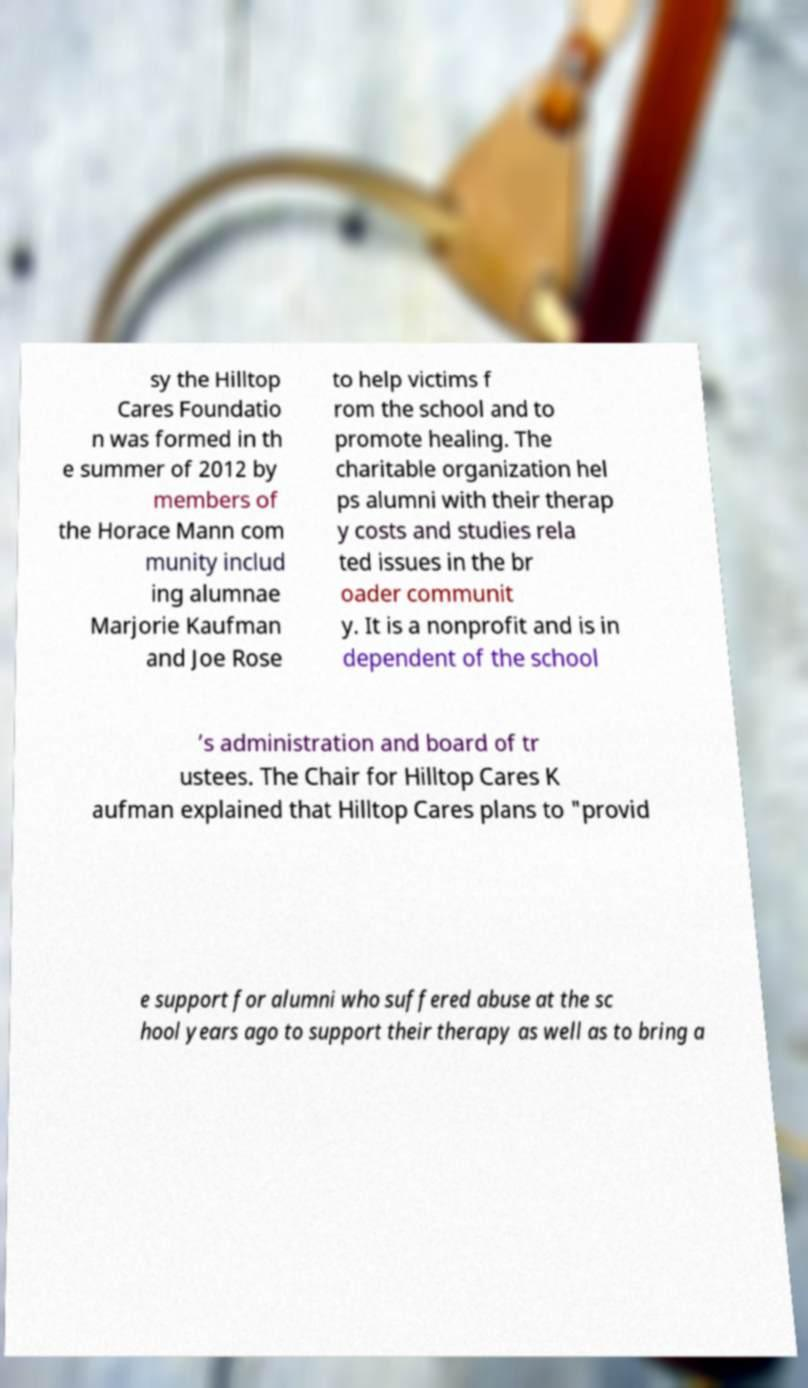Could you assist in decoding the text presented in this image and type it out clearly? sy the Hilltop Cares Foundatio n was formed in th e summer of 2012 by members of the Horace Mann com munity includ ing alumnae Marjorie Kaufman and Joe Rose to help victims f rom the school and to promote healing. The charitable organization hel ps alumni with their therap y costs and studies rela ted issues in the br oader communit y. It is a nonprofit and is in dependent of the school ’s administration and board of tr ustees. The Chair for Hilltop Cares K aufman explained that Hilltop Cares plans to "provid e support for alumni who suffered abuse at the sc hool years ago to support their therapy as well as to bring a 